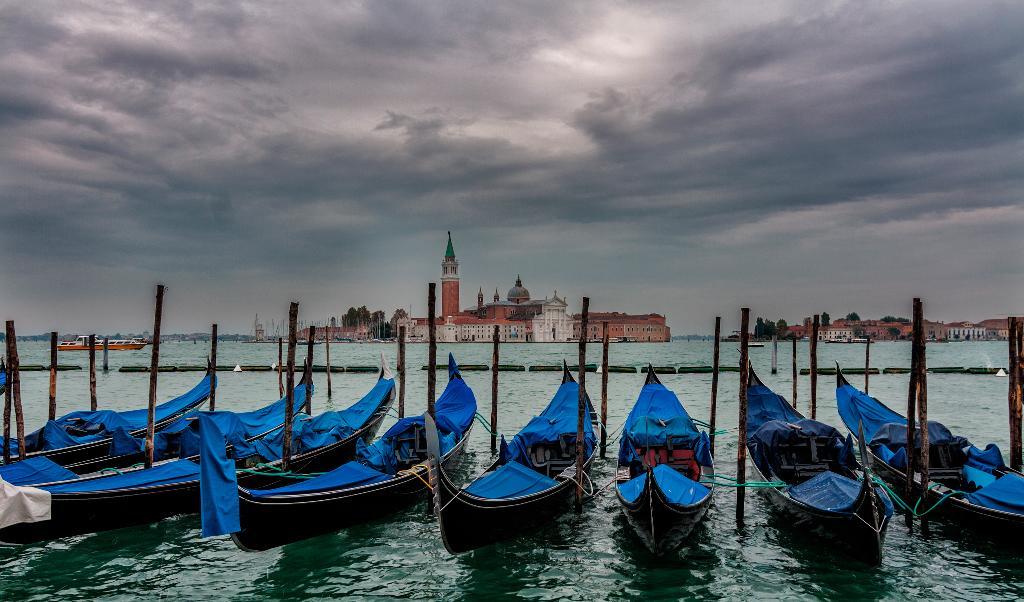How would you summarize this image in a sentence or two? In this picture we can see boats on water and in the background we can see buildings, trees, sky. 